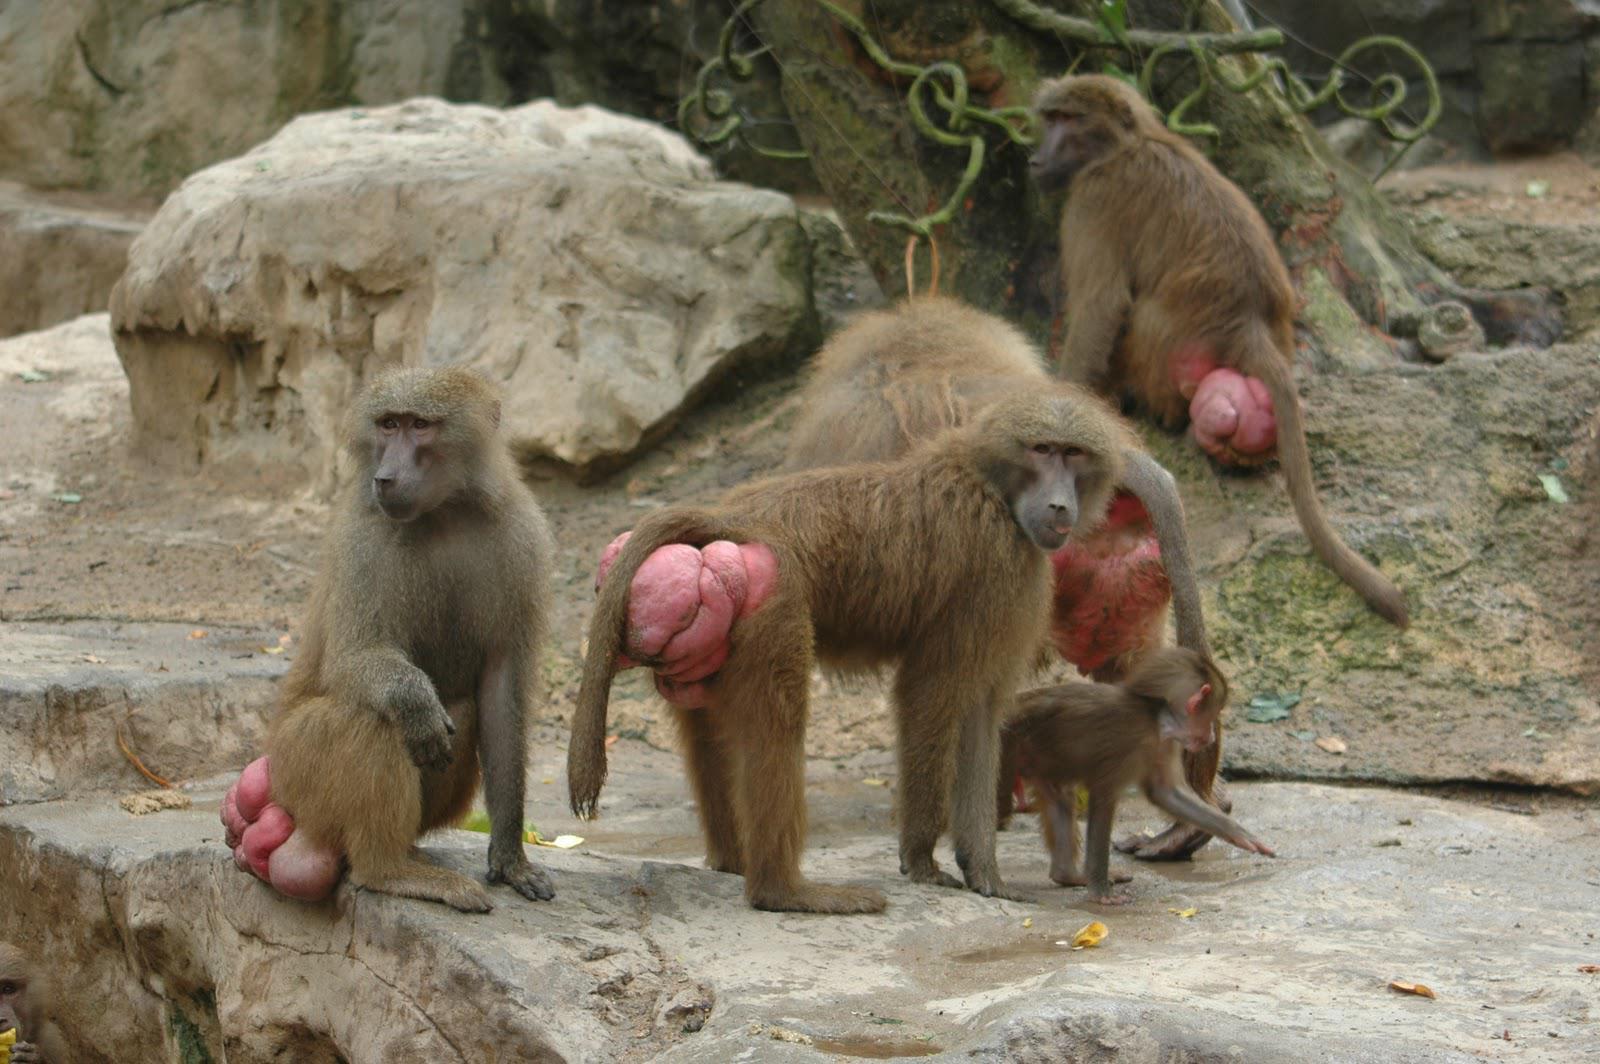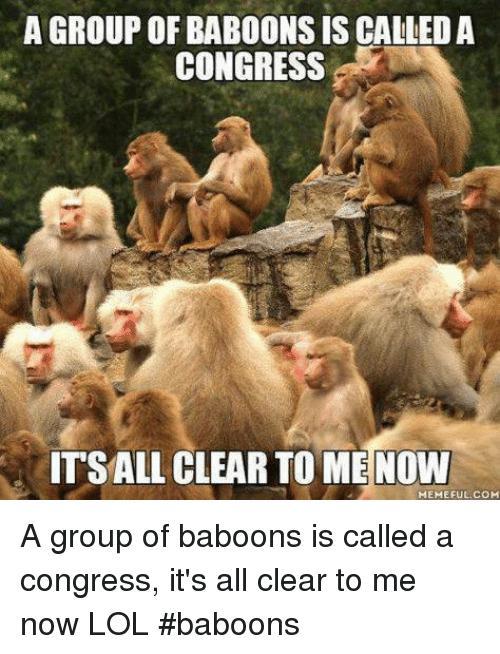The first image is the image on the left, the second image is the image on the right. Given the left and right images, does the statement "there are no more than four animals in the iage on the left" hold true? Answer yes or no. Yes. The first image is the image on the left, the second image is the image on the right. Examine the images to the left and right. Is the description "There are monkeys sitting on grass." accurate? Answer yes or no. No. 